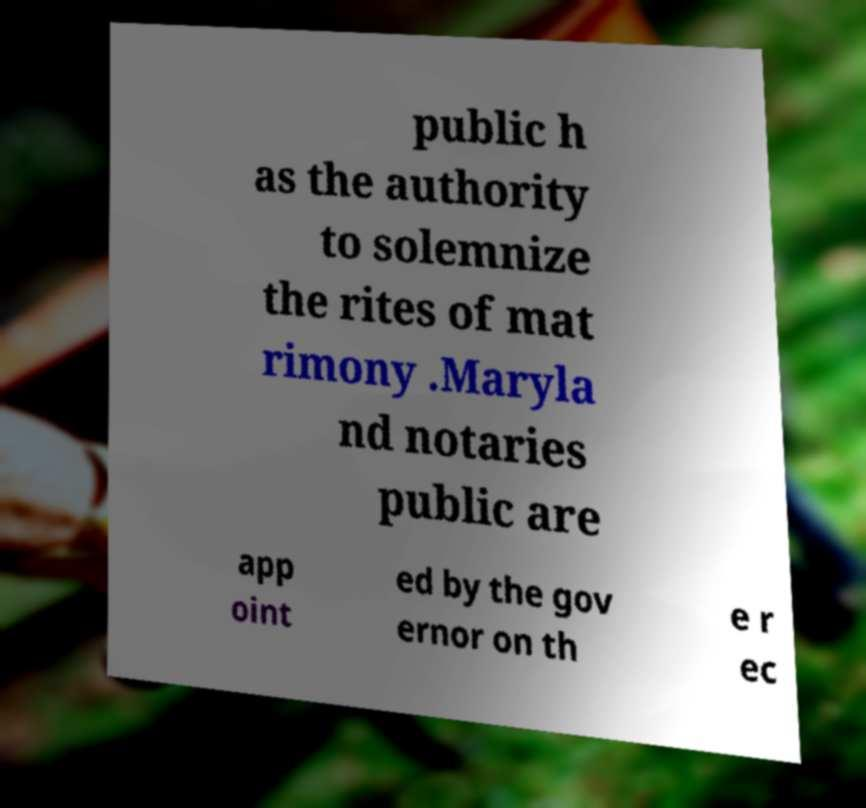Could you assist in decoding the text presented in this image and type it out clearly? public h as the authority to solemnize the rites of mat rimony .Maryla nd notaries public are app oint ed by the gov ernor on th e r ec 